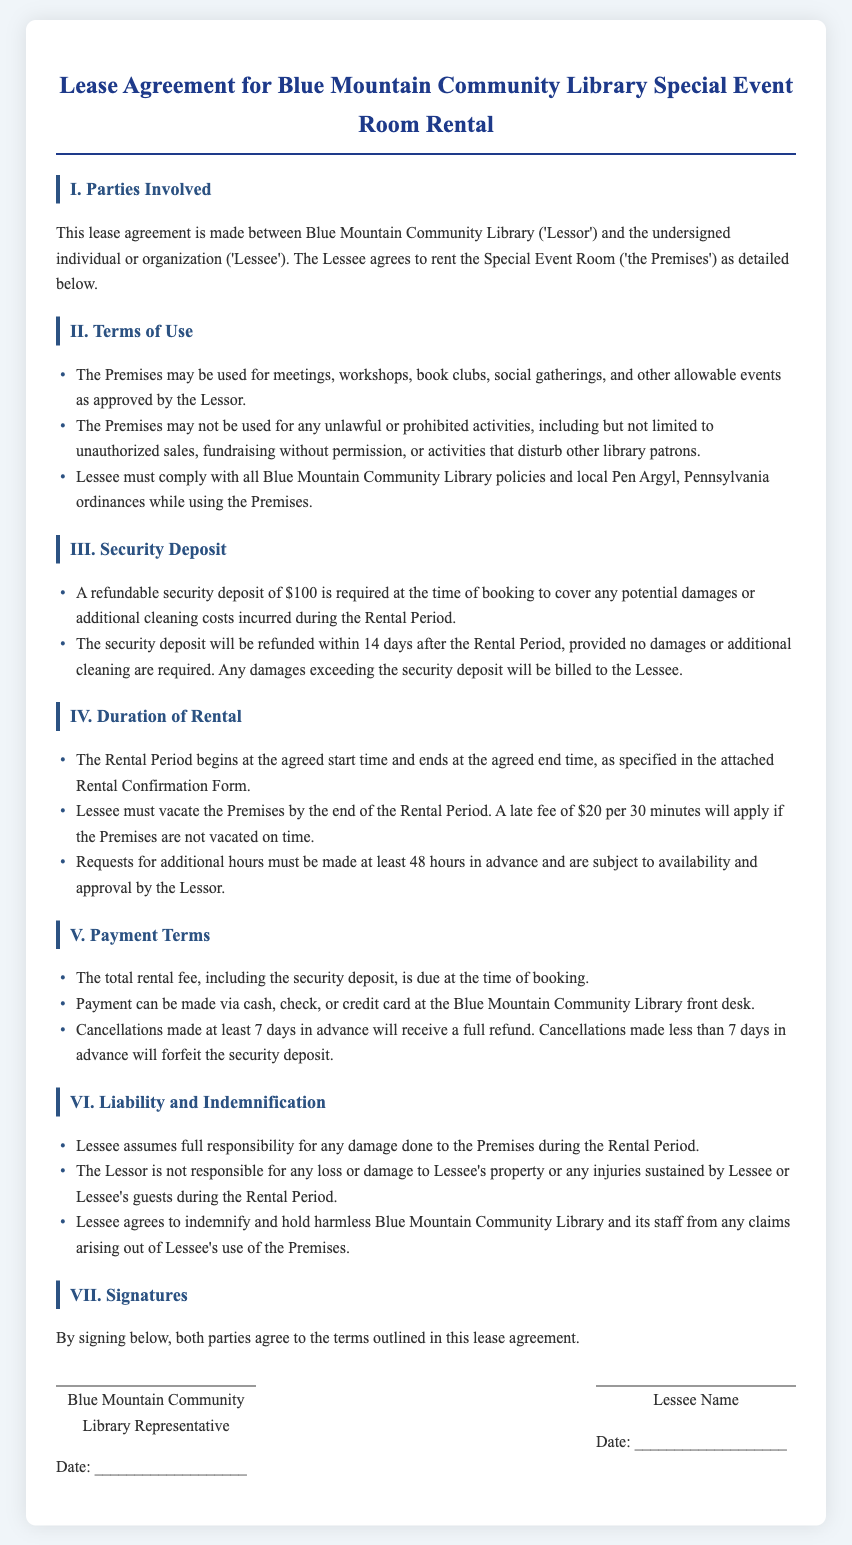What is the rental fee security deposit? The document states that a refundable security deposit is required at the time of booking to cover any potential damages.
Answer: $100 What is the late fee for not vacating the premises on time? The document specifies a late fee that applies if the premises are not vacated on time.
Answer: $20 per 30 minutes Who is responsible for damages during the rental period? The lease agreement states who is liable for damages incurred during the use of the premises.
Answer: Lessee What activities are prohibited in the event room? The terms of use outline specific activities that are disallowed while using the premises.
Answer: Unlawful activities How long after the rental period will the security deposit be refunded? The document specifies a timeframe for refunding the security deposit upon completion of the rental period.
Answer: 14 days What must be done 48 hours in advance regarding rental hours? The document mentions a requirement that must be fulfilled at least 48 hours before the rental period regarding time extensions.
Answer: Requests for additional hours What is the total fee due at the time of booking? The agreement mentions that a combined total must be provided when the booking is made.
Answer: The total rental fee, including the security deposit When must cancellations be made for a full refund? The document indicates a specific timeframe that must be adhered to for receiving a full refund upon cancellation.
Answer: At least 7 days in advance 